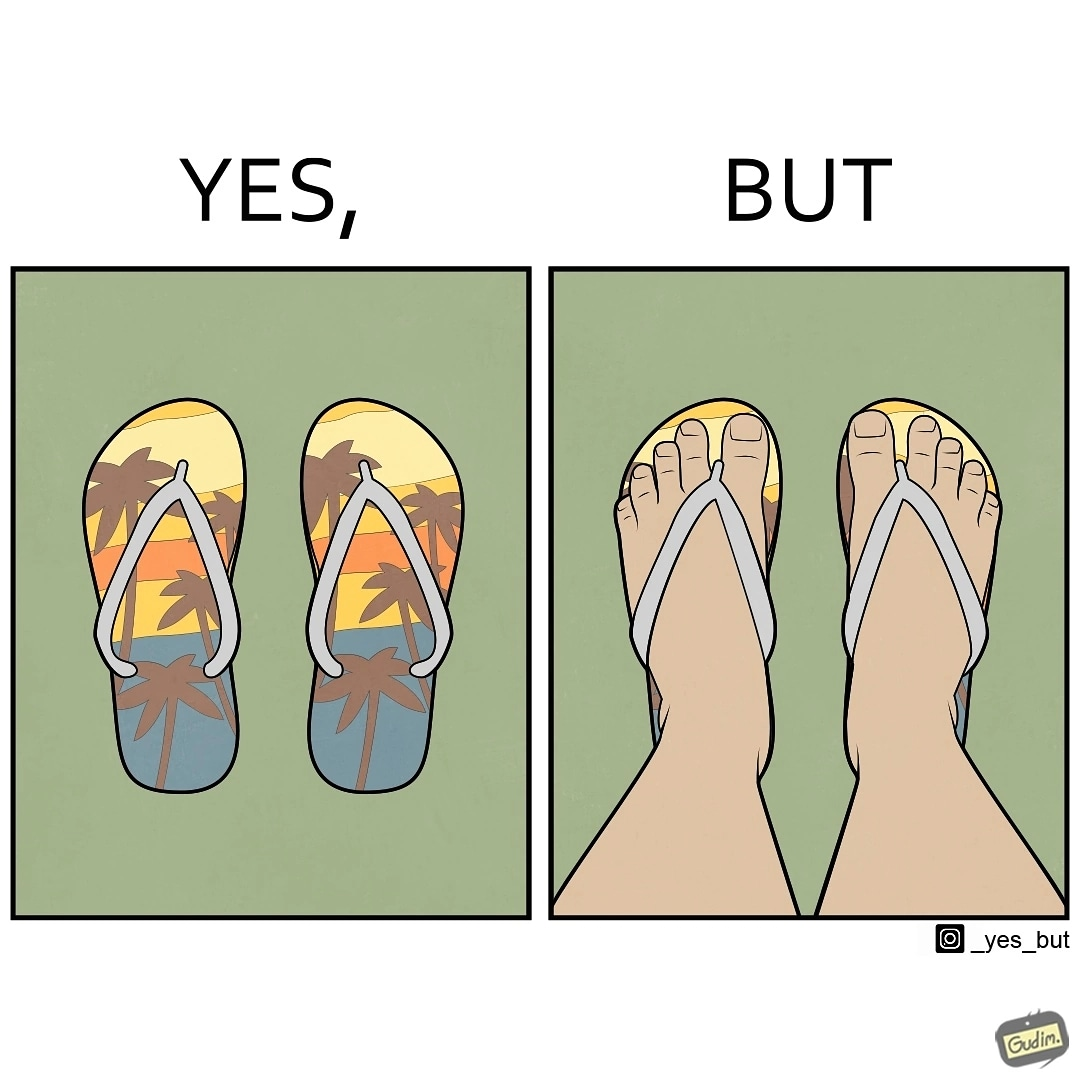Describe the contrast between the left and right parts of this image. In the left part of the image: Pair of colorful slippers, having an image of coconut trees probably in a beach by the sea during sunset. In the right part of the image: A person's legs wearing a pair of slippers. 